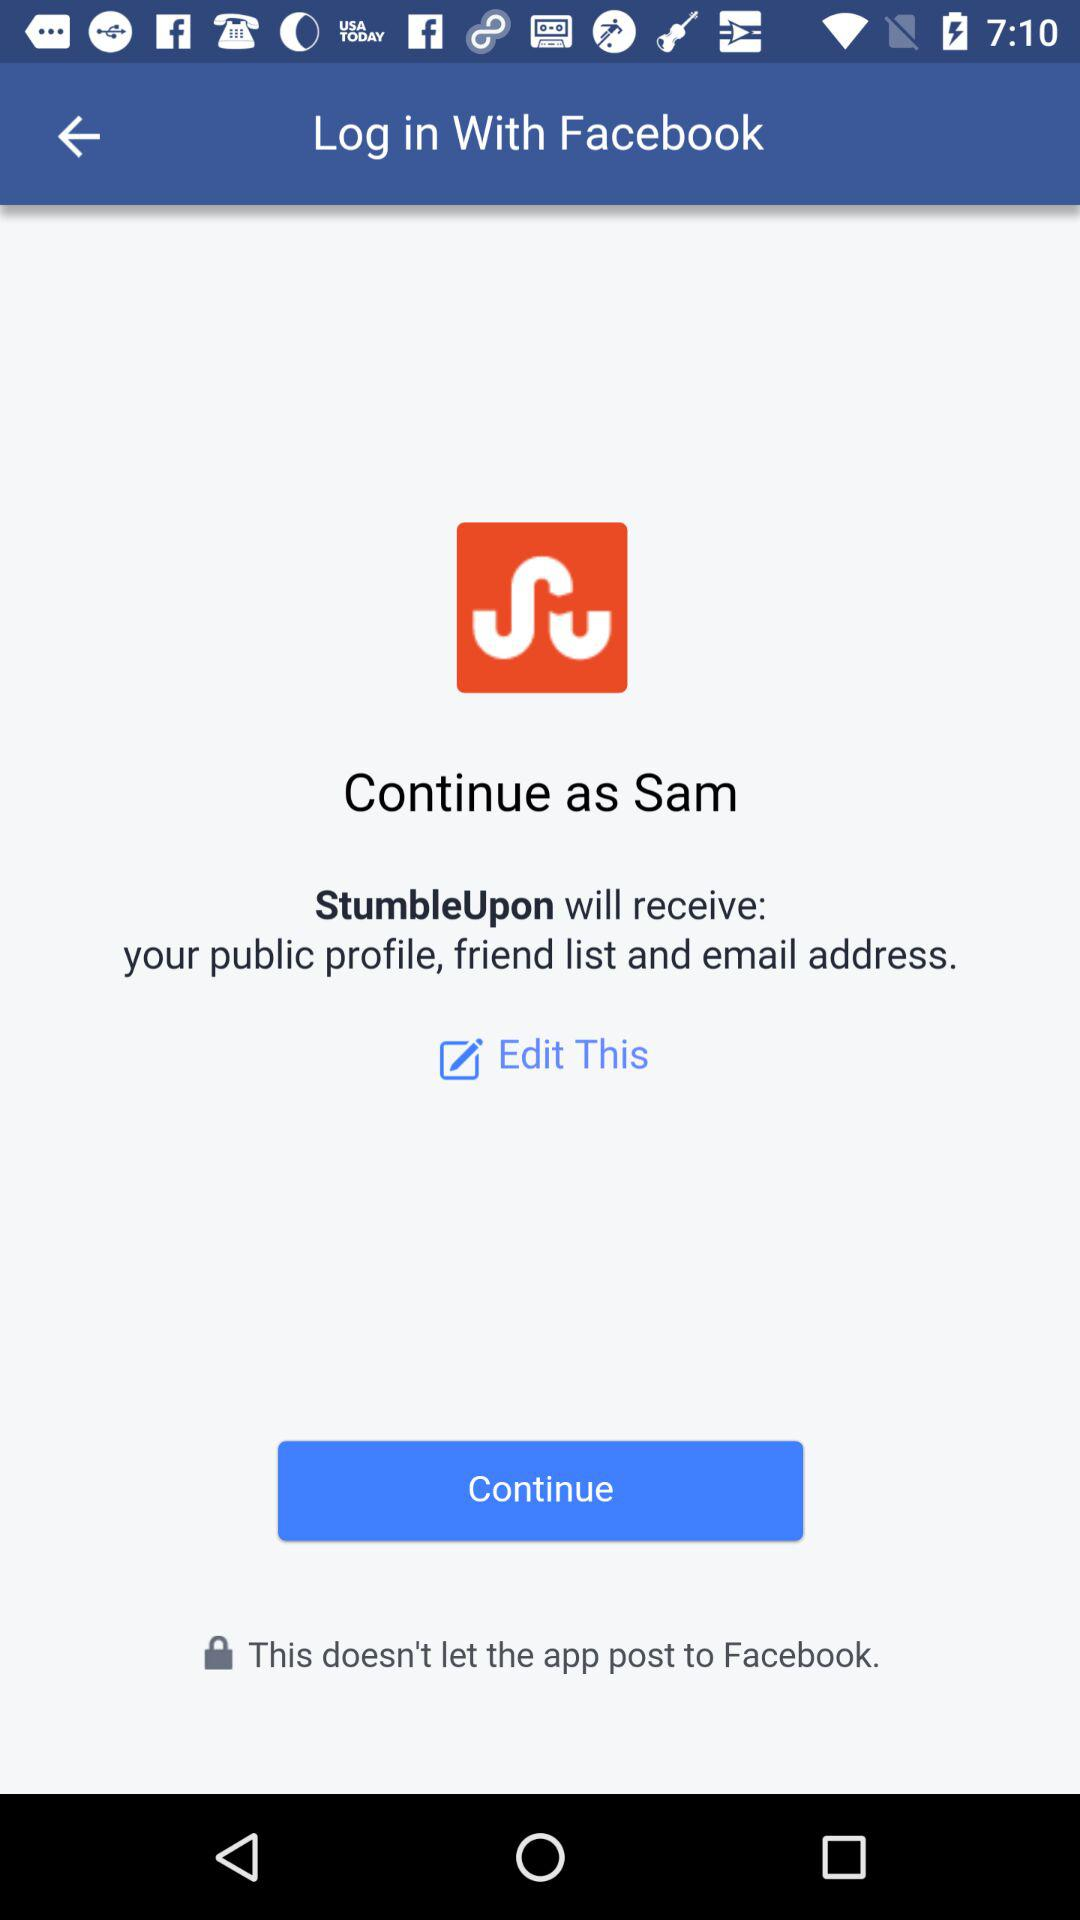Through what applications do we log in? The application is "Facebook". 